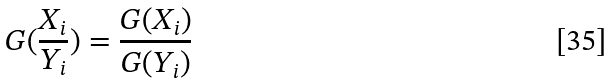<formula> <loc_0><loc_0><loc_500><loc_500>G ( \frac { X _ { i } } { Y _ { i } } ) = \frac { G ( X _ { i } ) } { G ( Y _ { i } ) }</formula> 